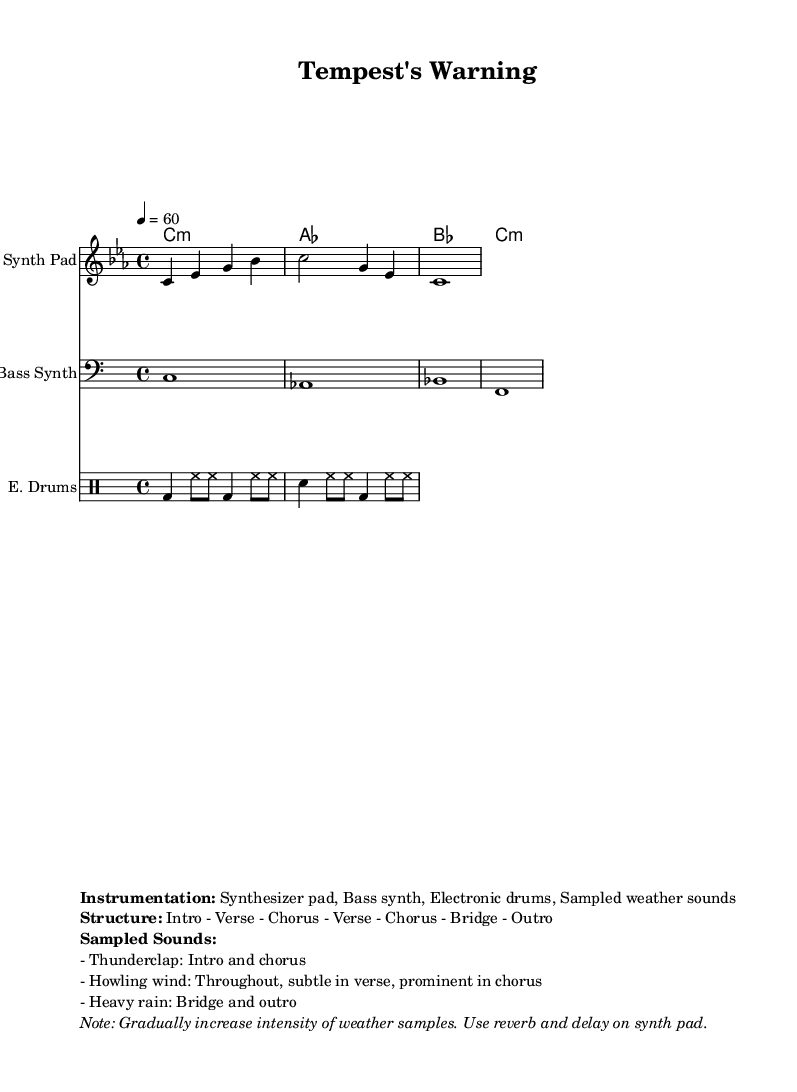What is the key signature of this music? The key signature is C minor, as indicated by the presence of three flats (B♭, E♭, and A♭) in the scale.
Answer: C minor What is the time signature of this music? The time signature is 4/4, which means there are four beats in each measure and the quarter note gets one beat.
Answer: 4/4 What is the tempo marking for this piece? The tempo marking indicates "4 = 60", meaning there are 60 beats per minute.
Answer: 60 What instruments are used in this composition? The instruments listed include a Synth Pad, Bass Synth, and Electronic Drums, along with sampled weather sounds.
Answer: Synth Pad, Bass Synth, Electronic Drums In which sections do the sampled sounds of heavy rain appear? The sample of heavy rain is specified to be present in the bridge and the outro of the composition.
Answer: Bridge and outro How is the intensity of weather samples intended to change throughout the piece? The note states that the intensity of the weather samples should gradually increase, adding dynamic variation to the performance.
Answer: Gradually increase What is the overall structure of the piece? The structure comprises several sections: Intro - Verse - Chorus - Verse - Chorus - Bridge - Outro, providing a clear layout for the progression of the music.
Answer: Intro - Verse - Chorus - Verse - Chorus - Bridge - Outro 